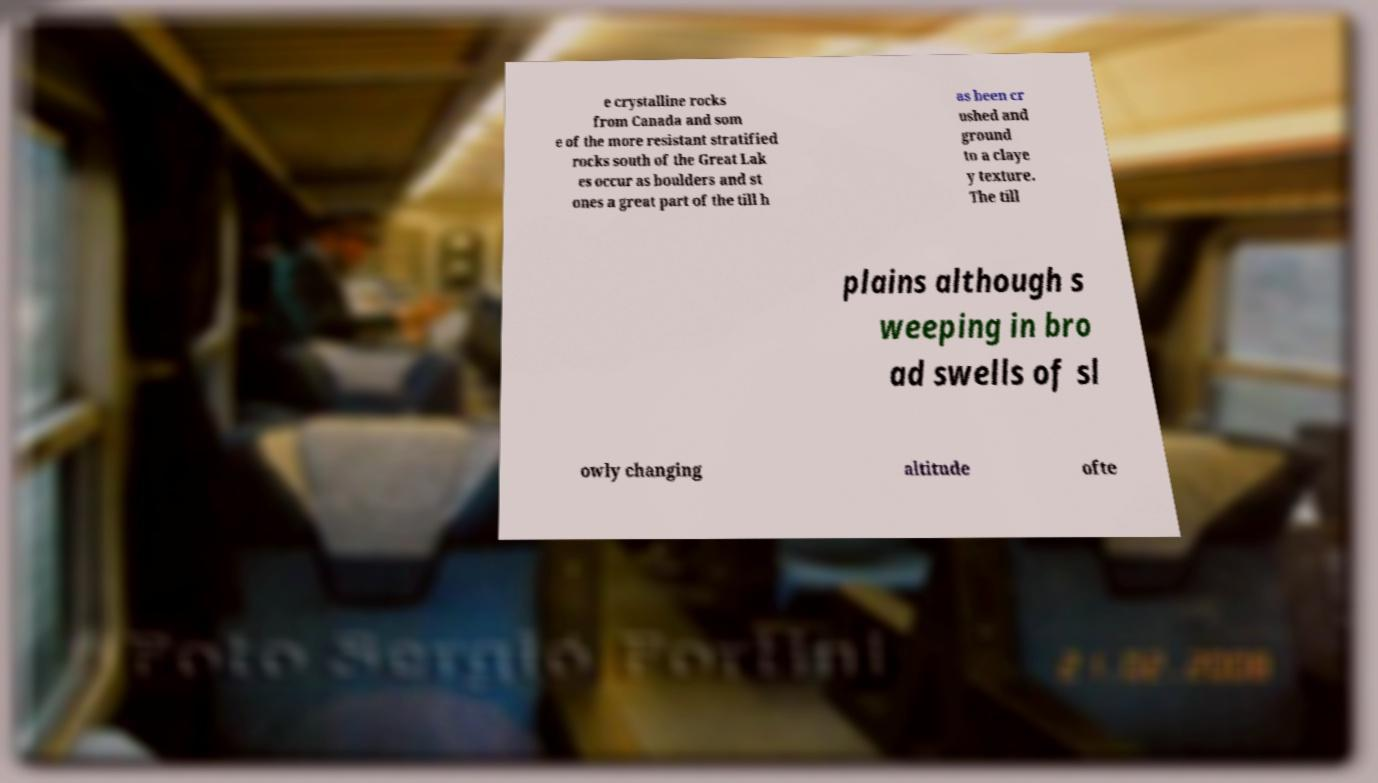Please identify and transcribe the text found in this image. e crystalline rocks from Canada and som e of the more resistant stratified rocks south of the Great Lak es occur as boulders and st ones a great part of the till h as been cr ushed and ground to a claye y texture. The till plains although s weeping in bro ad swells of sl owly changing altitude ofte 